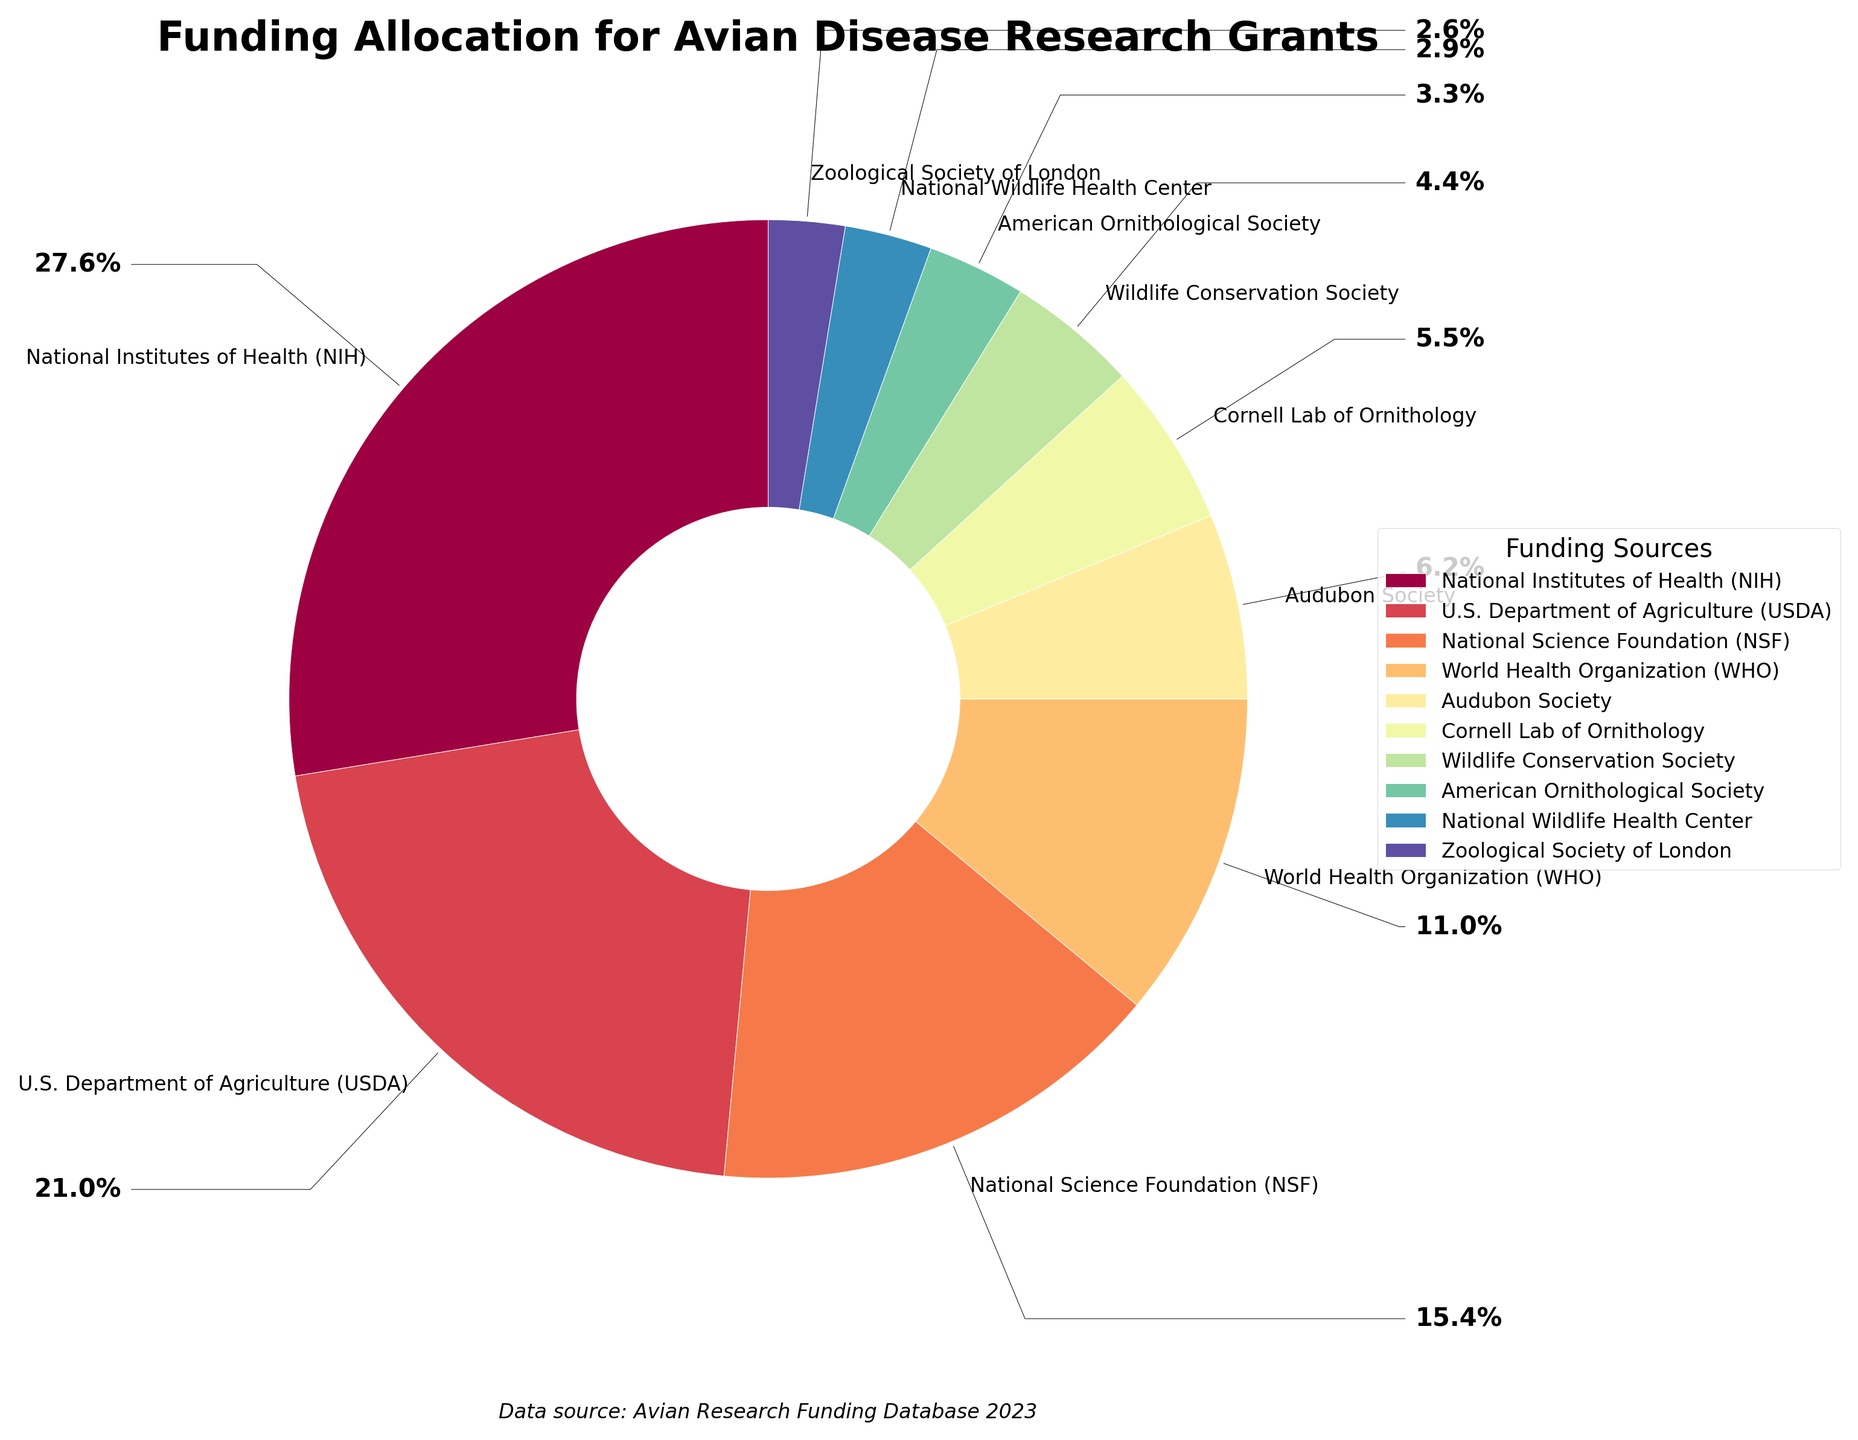Which funding source has the highest allocation? By looking at the pie chart, identify the segment with the largest size. The size corresponds to the funding amount.
Answer: National Institutes of Health (NIH) Which funding source contributes the least to avian disease research grants? By observing the pie chart, find the segment that has the smallest size. The smallest size represents the lowest funding amount.
Answer: Zoological Society of London What's the total contribution from both the USDA and the NSF? Identify the segments representing USDA and NSF, sum their respective funding amounts: USDA (2,850,000) + NSF (2,100,000).
Answer: 4,950,000 Which funding source provides more funds, the Audubon Society or the Cornell Lab of Ornithology? Compare the sizes of the segments labeled 'Audubon Society' and 'Cornell Lab of Ornithology'. The larger segment indicates the greater amount of funds.
Answer: Audubon Society What percentage of the total funding is contributed by the NIH? Identify the 'National Institutes of Health (NIH)' segment and refer to the associated percentage label.
Answer: 30.8% What is the combined percentage contribution of the NIH and WHO? Find the percentages for the 'National Institutes of Health (NIH)' and 'World Health Organization (WHO)' segments and add them together: NIH (30.8%) + WHO (12.3%).
Answer: 43.1% Out of the NSF and WHO, which organization provides less funding? Compare the sizes of the pie segments labeled 'National Science Foundation (NSF)' and 'World Health Organization (WHO)'. The smaller segment represents the lesser amount.
Answer: World Health Organization (WHO) If you combine the funding from the American Ornithological Society and National Wildlife Health Center, how many dollars does that amount to? Identify the segments for 'American Ornithological Society' and 'National Wildlife Health Center', sum their funding amounts: 450,000 + 400,000.
Answer: 850,000 What's the average funding amount contributed by the top three funding sources (NIH, USDA, NSF)? Add the funding amounts for NIH, USDA, NSF, and then divide by 3: (3,750,000 + 2,850,000 + 2,100,000) / 3.
Answer: 2,900,000 Which organization contributes more to avian disease research, the Wildlife Conservation Society or the American Ornithological Society? Compare the sizes of the segments for 'Wildlife Conservation Society' and 'American Ornithological Society'. The larger segment represents the greater funding contribution.
Answer: Wildlife Conservation Society 